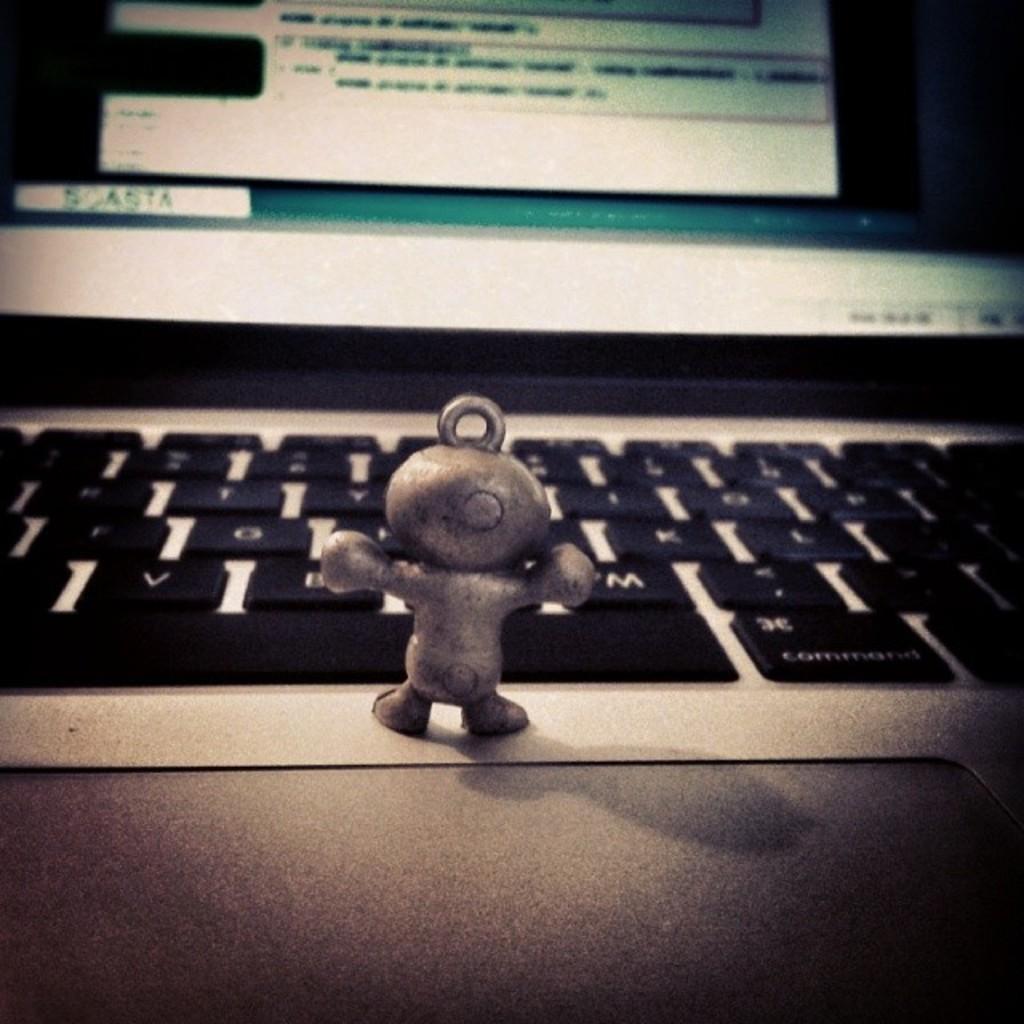How would you summarize this image in a sentence or two? In this image we can see a toy on the laptop, and the background is blurred. 